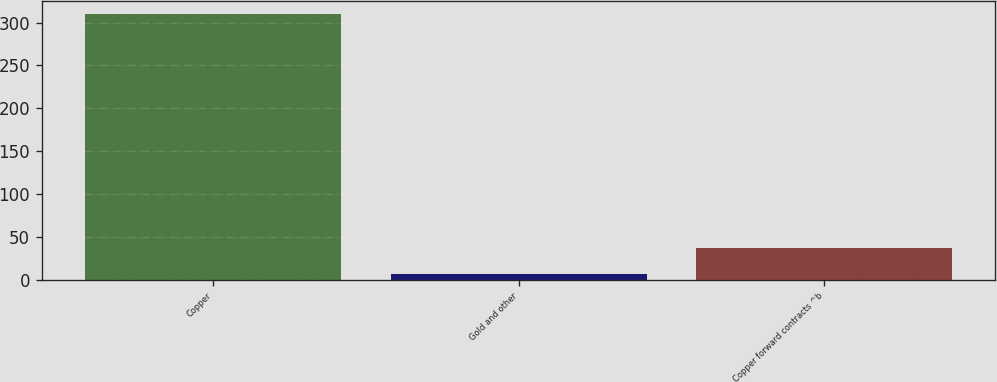<chart> <loc_0><loc_0><loc_500><loc_500><bar_chart><fcel>Copper<fcel>Gold and other<fcel>Copper forward contracts ^b<nl><fcel>310<fcel>7<fcel>37.3<nl></chart> 